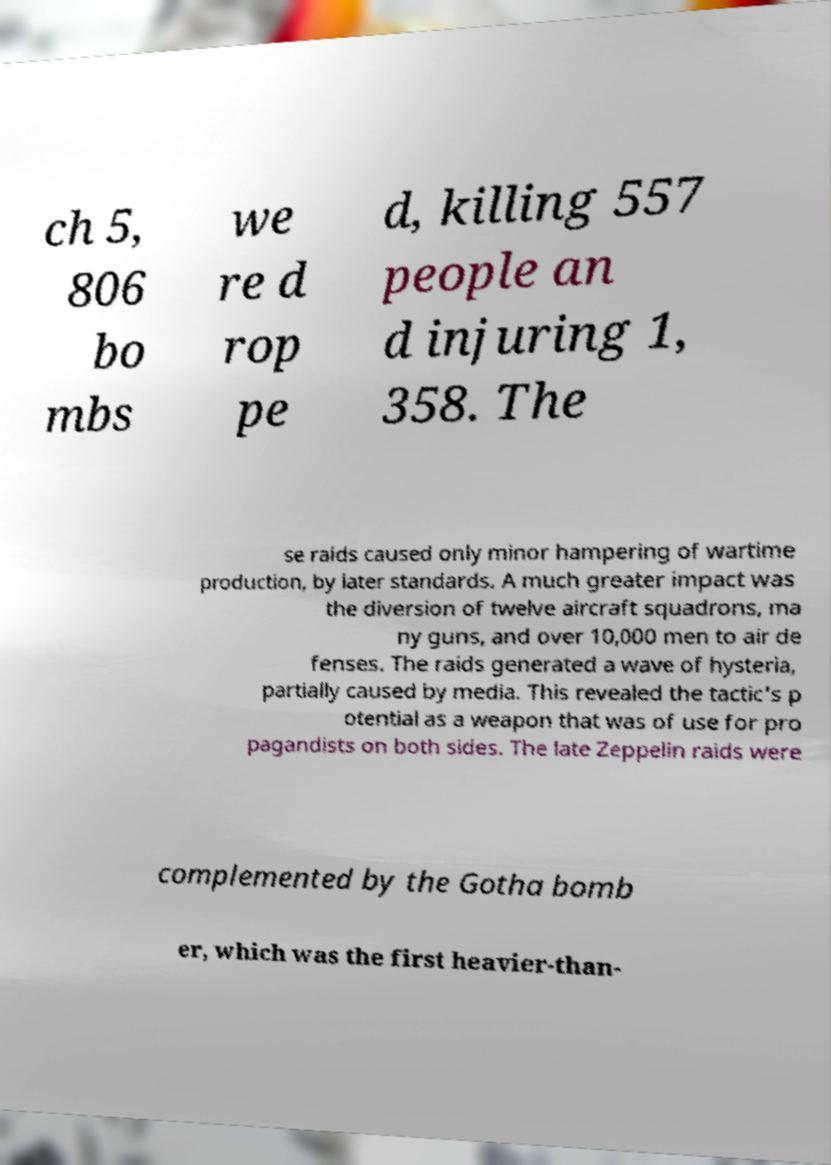Please read and relay the text visible in this image. What does it say? ch 5, 806 bo mbs we re d rop pe d, killing 557 people an d injuring 1, 358. The se raids caused only minor hampering of wartime production, by later standards. A much greater impact was the diversion of twelve aircraft squadrons, ma ny guns, and over 10,000 men to air de fenses. The raids generated a wave of hysteria, partially caused by media. This revealed the tactic's p otential as a weapon that was of use for pro pagandists on both sides. The late Zeppelin raids were complemented by the Gotha bomb er, which was the first heavier-than- 